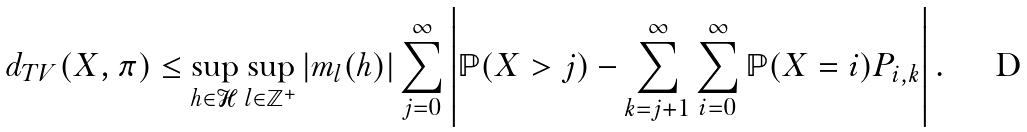<formula> <loc_0><loc_0><loc_500><loc_500>d _ { T V } ( X , \pi ) \leq \sup _ { h \in \mathcal { H } } \sup _ { l \in \mathbb { Z } ^ { + } } | m _ { l } ( h ) | \sum _ { j = 0 } ^ { \infty } \left | \mathbb { P } ( X > j ) - \sum _ { k = j + 1 } ^ { \infty } \sum _ { i = 0 } ^ { \infty } \mathbb { P } ( X = i ) P _ { i , k } \right | .</formula> 